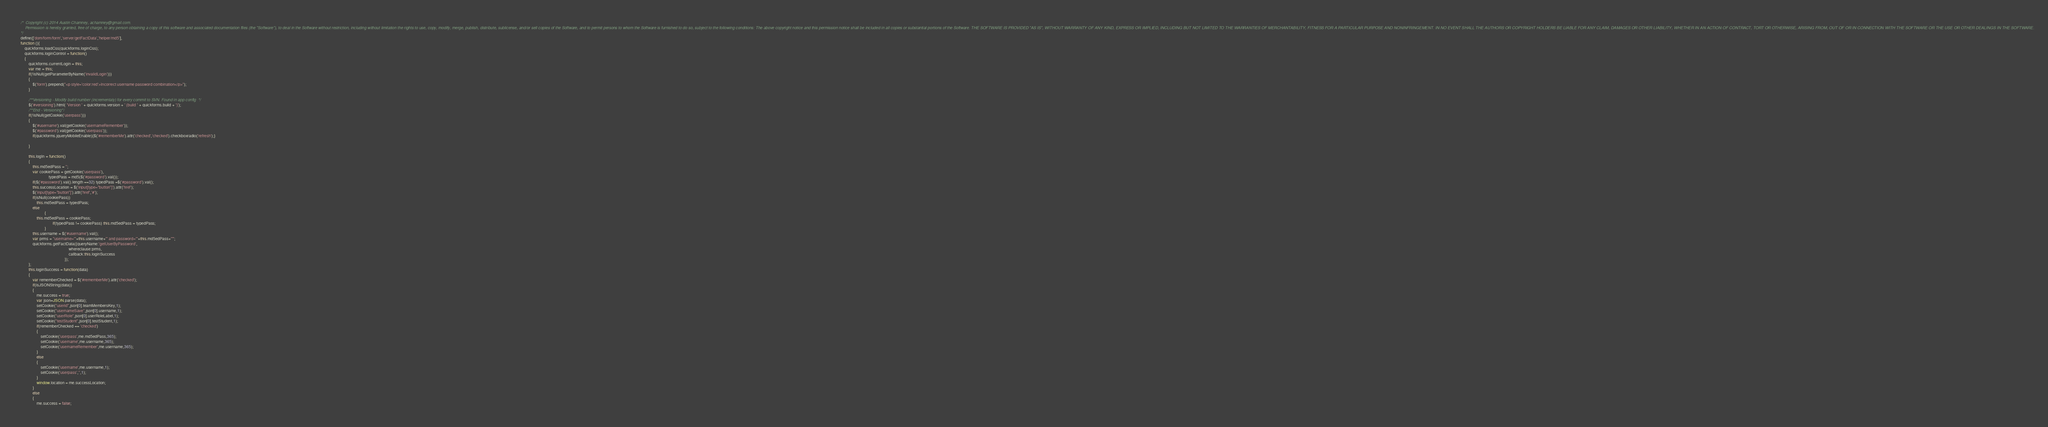<code> <loc_0><loc_0><loc_500><loc_500><_JavaScript_>/*  Copyright (c) 2014 Austin Chamney, achamney@gmail.com.
    Permission is hereby granted, free of charge, to any person obtaining a copy of this software and associated documentation files (the "Software"), to deal in the Software without restriction, including without limitation the rights to use, copy, modify, merge, publish, distribute, sublicense, and/or sell copies of the Software, and to permit persons to whom the Software is furnished to do so, subject to the following conditions: The above copyright notice and this permission notice shall be included in all copies or substantial portions of the Software. THE SOFTWARE IS PROVIDED "AS IS", WITHOUT WARRANTY OF ANY KIND, EXPRESS OR IMPLIED, INCLUDING BUT NOT LIMITED TO THE WARRANTIES OF MERCHANTABILITY, FITNESS FOR A PARTICULAR PURPOSE AND NONINFRINGEMENT. IN NO EVENT SHALL THE AUTHORS OR COPYRIGHT HOLDERS BE LIABLE FOR ANY CLAIM, DAMAGES OR OTHER LIABILITY, WHETHER IN AN ACTION OF CONTRACT, TORT OR OTHERWISE, ARISING FROM, OUT OF OR IN CONNECTION WITH THE SOFTWARE OR THE USE OR OTHER DEALINGS IN THE SOFTWARE.
*/
define(['dom/form/form','server/getFactData','helper/md5'],
function (){
	quickforms.loadCss(quickforms.loginCss);
	quickforms.loginControl = function()
	{
		quickforms.currentLogin = this;
		var me = this;
		if(!isNull(getParameterByName('invalidLogin')))
		{
			$('form').prepend("<p style='color:red'>Incorrect username password combination</p>");
		}
		
		/**Versioning - Modify build number (incrementaly) for every commit to SVN. Found in app config  */
		$('#versioning').html( 'Version ' + quickforms.version + ' (build ' + quickforms.build + ')');
		/**End - Versioning*/
		if(!isNull(getCookie('userpass')))
		{
			$('#username').val(getCookie('usernameRemember'));
			$('#password').val(getCookie('userpass'));
			if(quickforms.jqueryMobileEnable){$('#rememberMe').attr('checked','checked').checkboxradio('refresh');}
			
		}
					   
		this.logIn = function()
		{
			this.md5edPass = '';
			var cookiePass = getCookie('userpass'),
                            typedPass = md5($('#password').val());
			if($('#password').val().length ==32) typedPass =$('#password').val();
			this.successLocation = $('input[type="button"]').attr('href');
			$('input[type="button"]').attr('href','#');
			if(isNull(cookiePass))
				this.md5edPass = typedPass;
			else
                        {
				this.md5edPass = cookiePass;
                                if(typedPass != cookiePass) this.md5edPass = typedPass;
                        }
			this.username = $('#username').val();
			var prms = "username='"+this.username+"' and password='"+this.md5edPass+"'";
			quickforms.getFactData({queryName:'getUserByPassword',
                                                whereclause:prms,
                                                callback:this.loginSuccess
                                            });
		};
		this.loginSuccess = function(data)
		{
			var rememberChecked = $('#rememberMe').attr('checked');
			if(isJSONString(data))
			{
				me.success = true;
				var json=JSON.parse(data);
				setCookie("userid",json[0].teamMembersKey,1);
				setCookie("usernameSave",json[0].username,1);
				setCookie("userRole",json[0].userRoleLabel,1);
				setCookie("testStudent",json[0].testStudent,1);
				if(rememberChecked == 'checked')
				{
					setCookie('userpass',me.md5edPass,365);
					setCookie('username',me.username,365);
					setCookie('usernameRemember',me.username,365);
				}
				else
				{
					setCookie('username',me.username,1);
					setCookie('userpass','',1);
				}
				window.location = me.successLocation;
			}
			else
			{
				me.success = false;</code> 